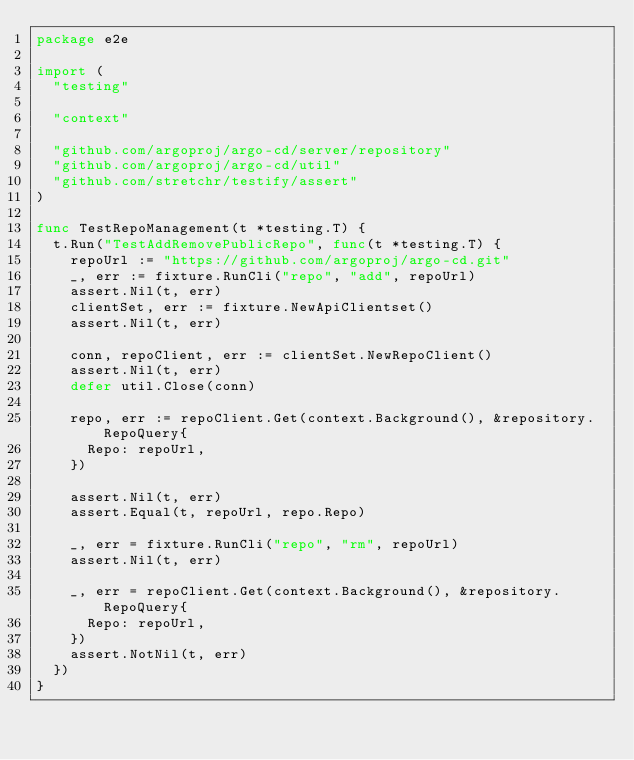<code> <loc_0><loc_0><loc_500><loc_500><_Go_>package e2e

import (
	"testing"

	"context"

	"github.com/argoproj/argo-cd/server/repository"
	"github.com/argoproj/argo-cd/util"
	"github.com/stretchr/testify/assert"
)

func TestRepoManagement(t *testing.T) {
	t.Run("TestAddRemovePublicRepo", func(t *testing.T) {
		repoUrl := "https://github.com/argoproj/argo-cd.git"
		_, err := fixture.RunCli("repo", "add", repoUrl)
		assert.Nil(t, err)
		clientSet, err := fixture.NewApiClientset()
		assert.Nil(t, err)

		conn, repoClient, err := clientSet.NewRepoClient()
		assert.Nil(t, err)
		defer util.Close(conn)

		repo, err := repoClient.Get(context.Background(), &repository.RepoQuery{
			Repo: repoUrl,
		})

		assert.Nil(t, err)
		assert.Equal(t, repoUrl, repo.Repo)

		_, err = fixture.RunCli("repo", "rm", repoUrl)
		assert.Nil(t, err)

		_, err = repoClient.Get(context.Background(), &repository.RepoQuery{
			Repo: repoUrl,
		})
		assert.NotNil(t, err)
	})
}
</code> 